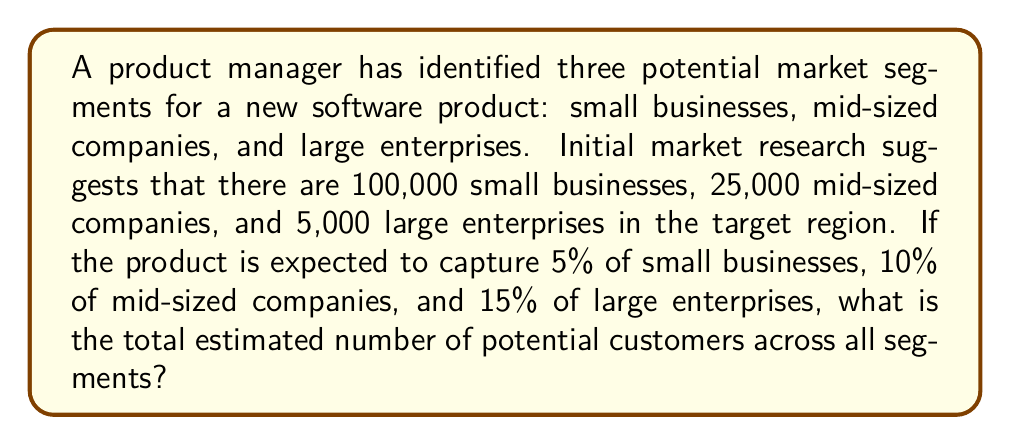Solve this math problem. To solve this problem, we need to calculate the number of potential customers in each segment and then sum them up. Let's break it down step-by-step:

1. Small businesses:
   - Total number: 100,000
   - Expected capture rate: 5%
   - Potential customers: $100,000 \times 0.05 = 5,000$

2. Mid-sized companies:
   - Total number: 25,000
   - Expected capture rate: 10%
   - Potential customers: $25,000 \times 0.10 = 2,500$

3. Large enterprises:
   - Total number: 5,000
   - Expected capture rate: 15%
   - Potential customers: $5,000 \times 0.15 = 750$

4. Total estimated number of potential customers:
   $$ \text{Total} = 5,000 + 2,500 + 750 = 8,250 $$

Therefore, the total estimated number of potential customers across all segments is 8,250.
Answer: 8,250 